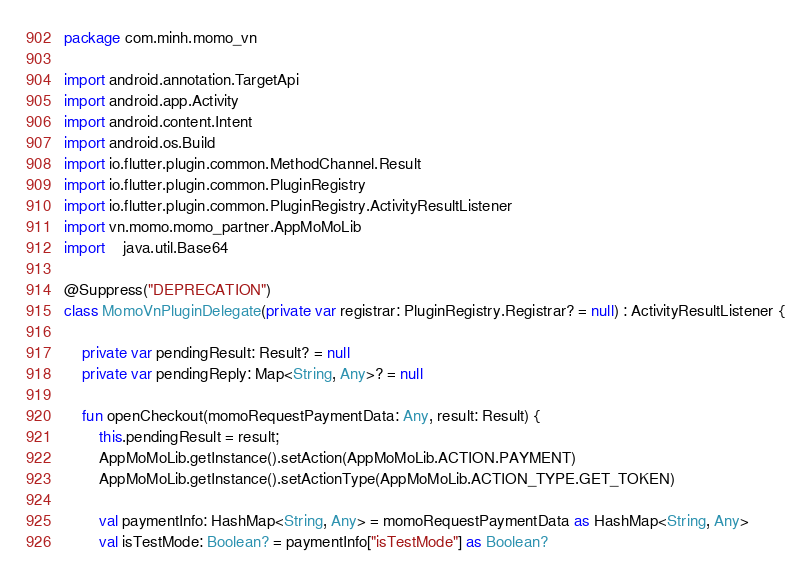<code> <loc_0><loc_0><loc_500><loc_500><_Kotlin_>package com.minh.momo_vn

import android.annotation.TargetApi
import android.app.Activity
import android.content.Intent
import android.os.Build
import io.flutter.plugin.common.MethodChannel.Result
import io.flutter.plugin.common.PluginRegistry
import io.flutter.plugin.common.PluginRegistry.ActivityResultListener
import vn.momo.momo_partner.AppMoMoLib
import 	java.util.Base64

@Suppress("DEPRECATION")
class MomoVnPluginDelegate(private var registrar: PluginRegistry.Registrar? = null) : ActivityResultListener {

    private var pendingResult: Result? = null
    private var pendingReply: Map<String, Any>? = null

    fun openCheckout(momoRequestPaymentData: Any, result: Result) {
        this.pendingResult = result;
        AppMoMoLib.getInstance().setAction(AppMoMoLib.ACTION.PAYMENT)
        AppMoMoLib.getInstance().setActionType(AppMoMoLib.ACTION_TYPE.GET_TOKEN)

        val paymentInfo: HashMap<String, Any> = momoRequestPaymentData as HashMap<String, Any>
        val isTestMode: Boolean? = paymentInfo["isTestMode"] as Boolean?
</code> 